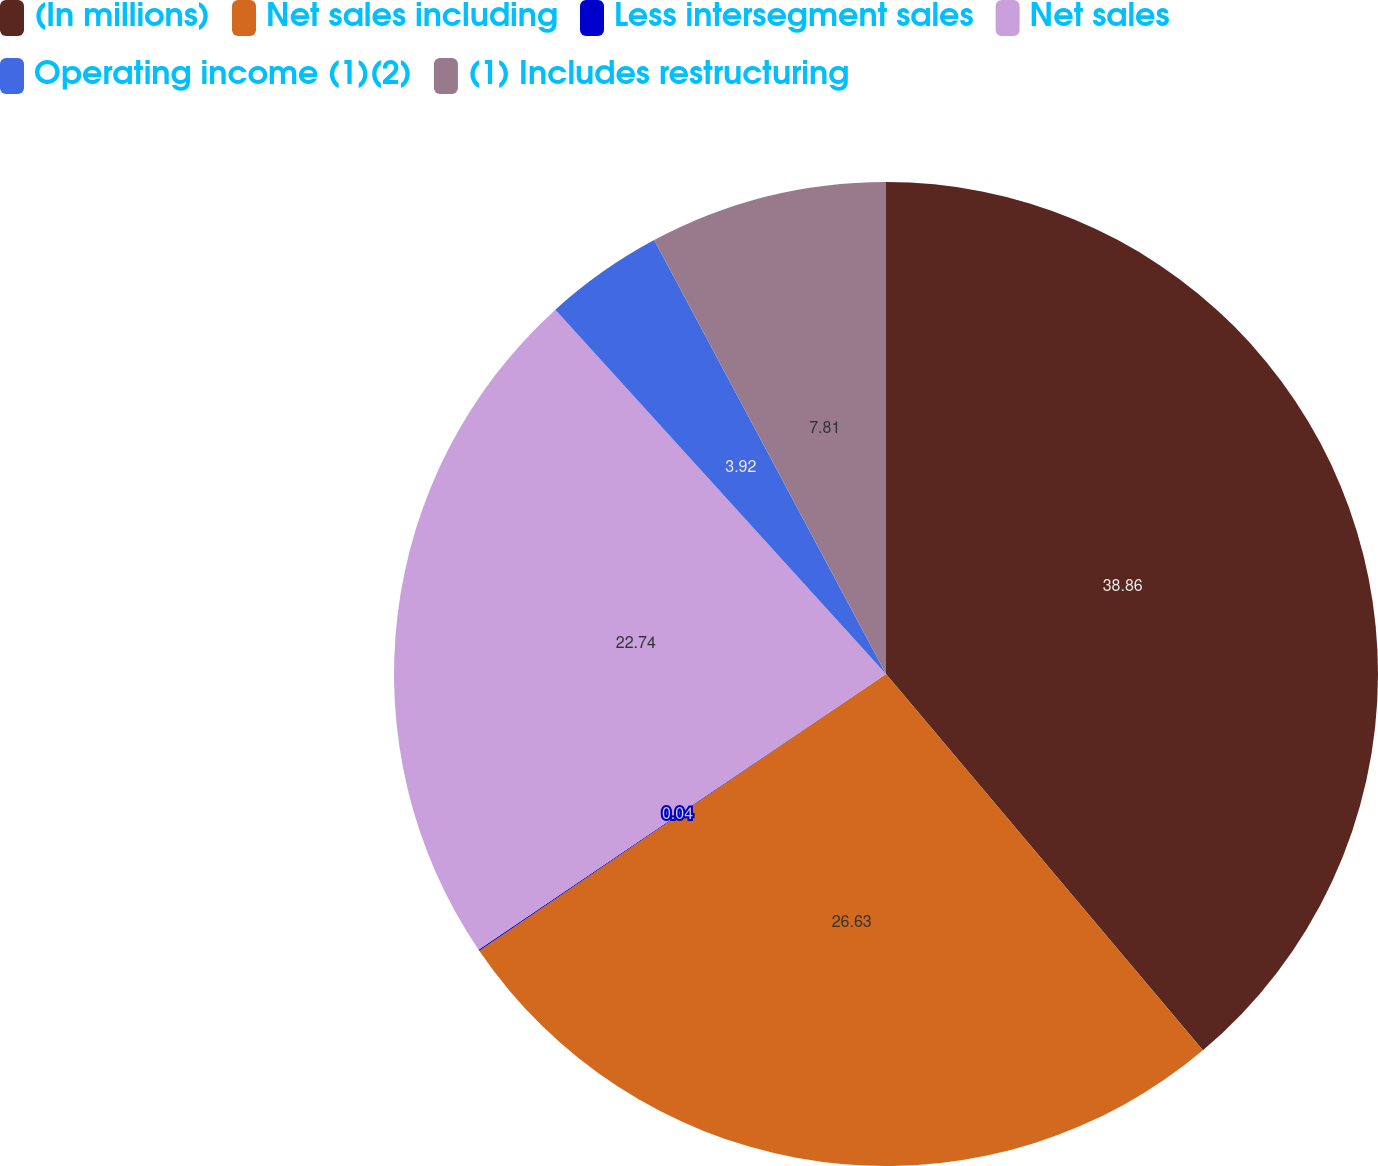Convert chart to OTSL. <chart><loc_0><loc_0><loc_500><loc_500><pie_chart><fcel>(In millions)<fcel>Net sales including<fcel>Less intersegment sales<fcel>Net sales<fcel>Operating income (1)(2)<fcel>(1) Includes restructuring<nl><fcel>38.86%<fcel>26.63%<fcel>0.04%<fcel>22.74%<fcel>3.92%<fcel>7.81%<nl></chart> 